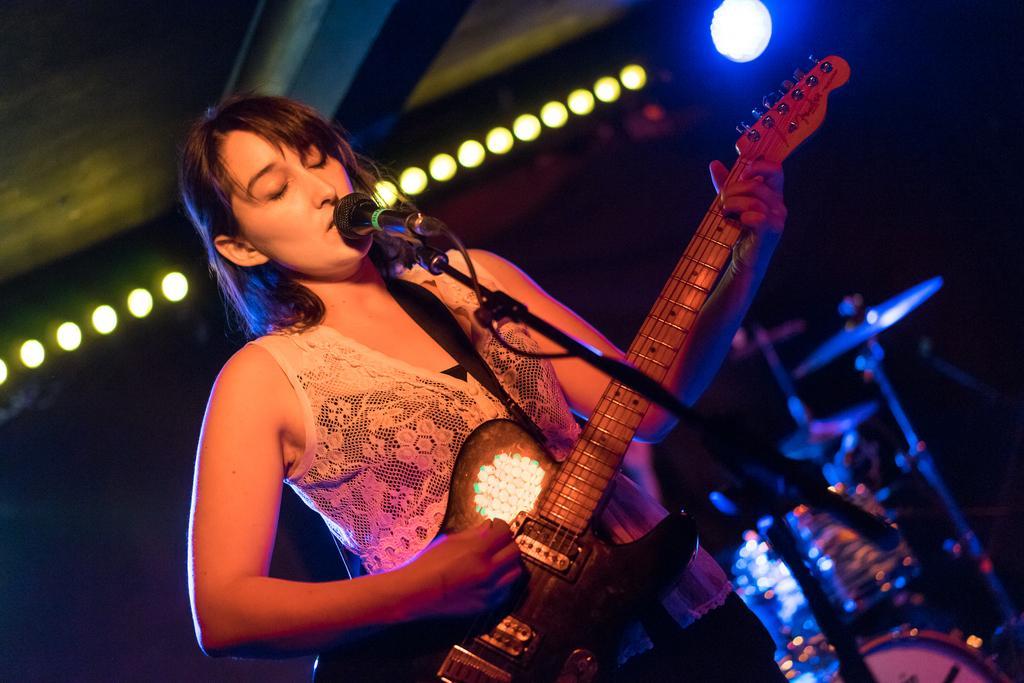How would you summarize this image in a sentence or two? This is a picture of a women, the woman is singing a song and playing a guitar. This is a microphone and this is a stand and background of the women is a music instruments and a wall with lights. 